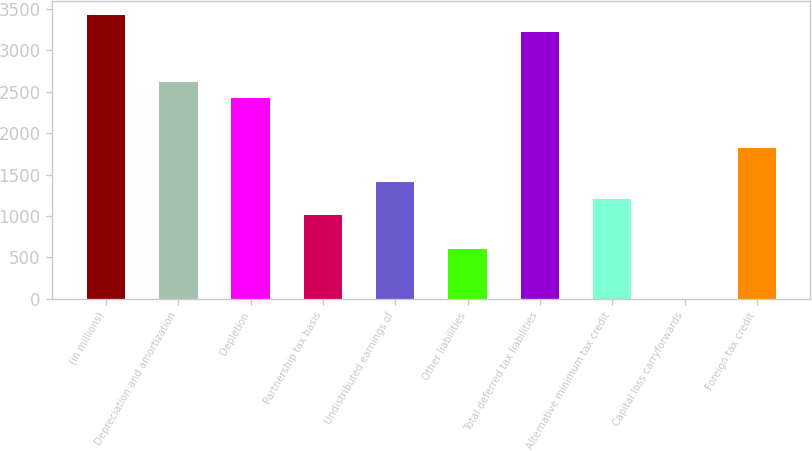Convert chart to OTSL. <chart><loc_0><loc_0><loc_500><loc_500><bar_chart><fcel>(in millions)<fcel>Depreciation and amortization<fcel>Depletion<fcel>Partnership tax basis<fcel>Undistributed earnings of<fcel>Other liabilities<fcel>Total deferred tax liabilities<fcel>Alternative minimum tax credit<fcel>Capital loss carryforwards<fcel>Foreign tax credit<nl><fcel>3423.61<fcel>2618.69<fcel>2417.46<fcel>1008.85<fcel>1411.31<fcel>606.39<fcel>3222.38<fcel>1210.08<fcel>2.7<fcel>1813.77<nl></chart> 